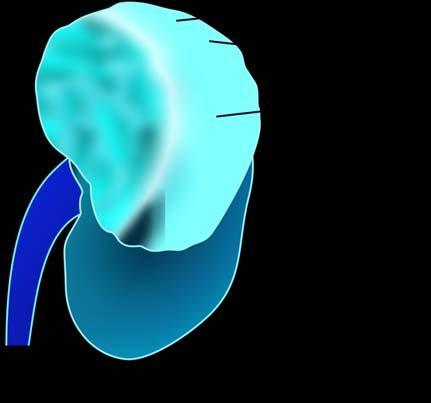does rest of the kidney have reniform contour?
Answer the question using a single word or phrase. Yes 